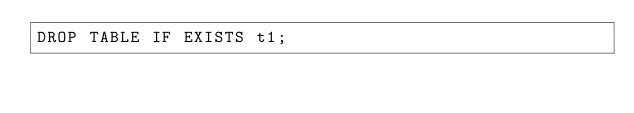<code> <loc_0><loc_0><loc_500><loc_500><_SQL_>DROP TABLE IF EXISTS t1;
</code> 